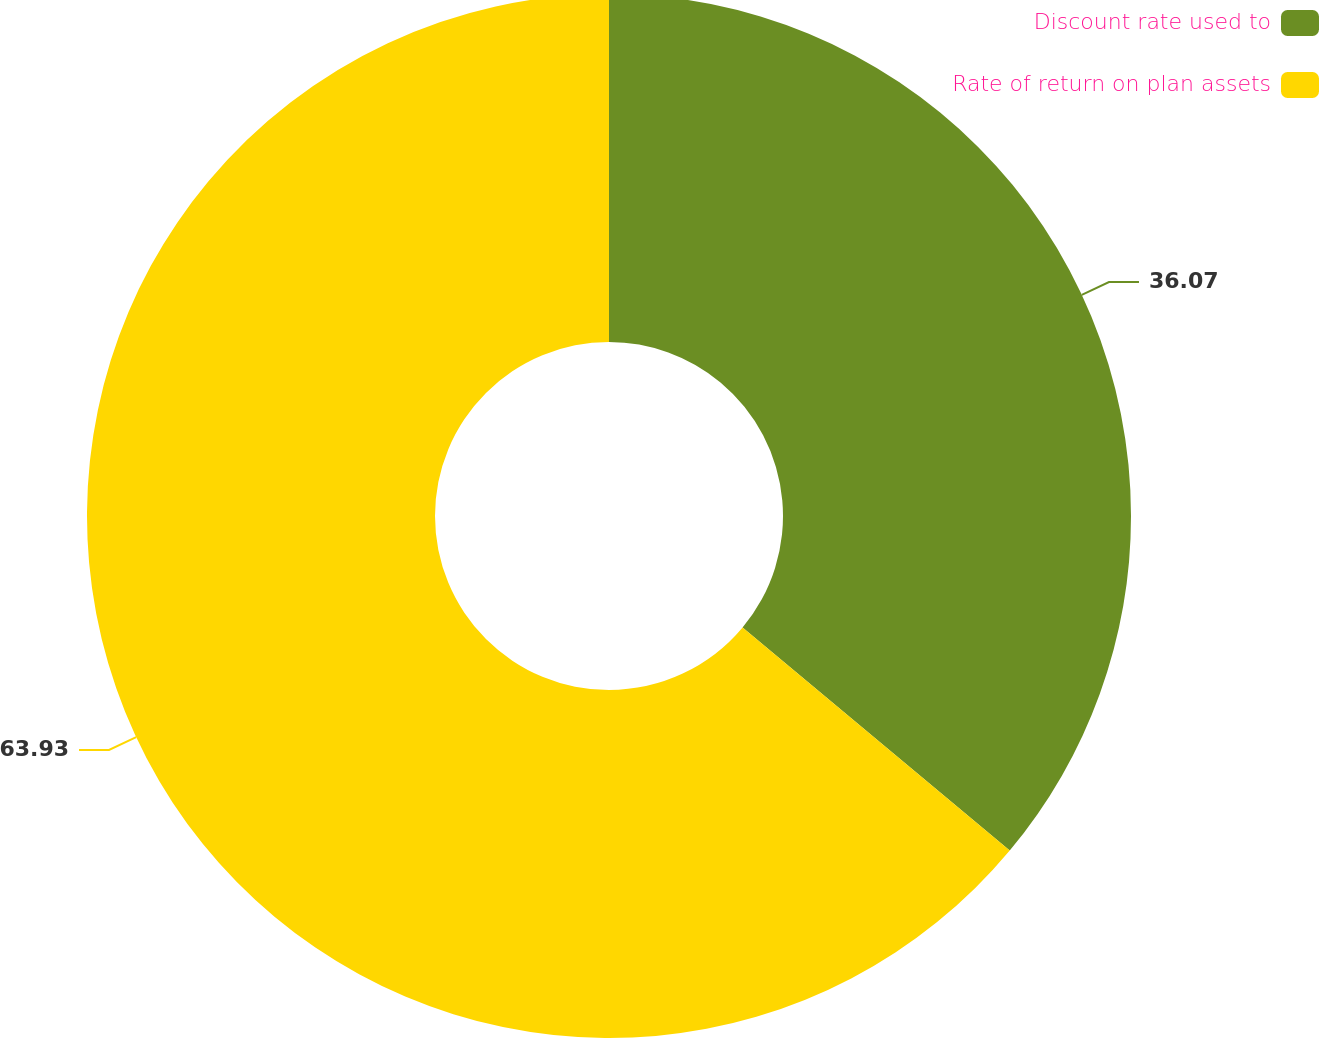Convert chart to OTSL. <chart><loc_0><loc_0><loc_500><loc_500><pie_chart><fcel>Discount rate used to<fcel>Rate of return on plan assets<nl><fcel>36.07%<fcel>63.93%<nl></chart> 